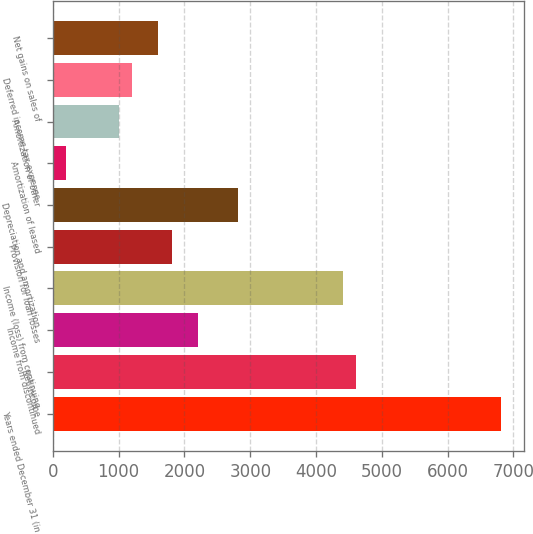Convert chart to OTSL. <chart><loc_0><loc_0><loc_500><loc_500><bar_chart><fcel>Years ended December 31 (in<fcel>Net income<fcel>Income from discontinued<fcel>Income (loss) from continuing<fcel>Provision for loan losses<fcel>Depreciation and amortization<fcel>Amortization of leased<fcel>Amortization of other<fcel>Deferred income tax expense<fcel>Net gains on sales of<nl><fcel>6815.56<fcel>4610.72<fcel>2205.44<fcel>4410.28<fcel>1804.56<fcel>2806.76<fcel>201.04<fcel>1002.8<fcel>1203.24<fcel>1604.12<nl></chart> 